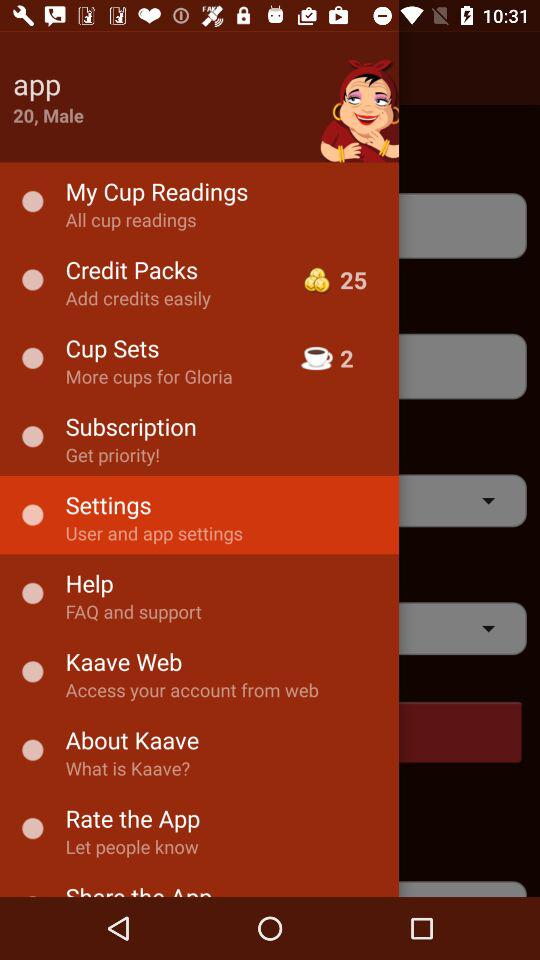What is the gender? The gender is male. 